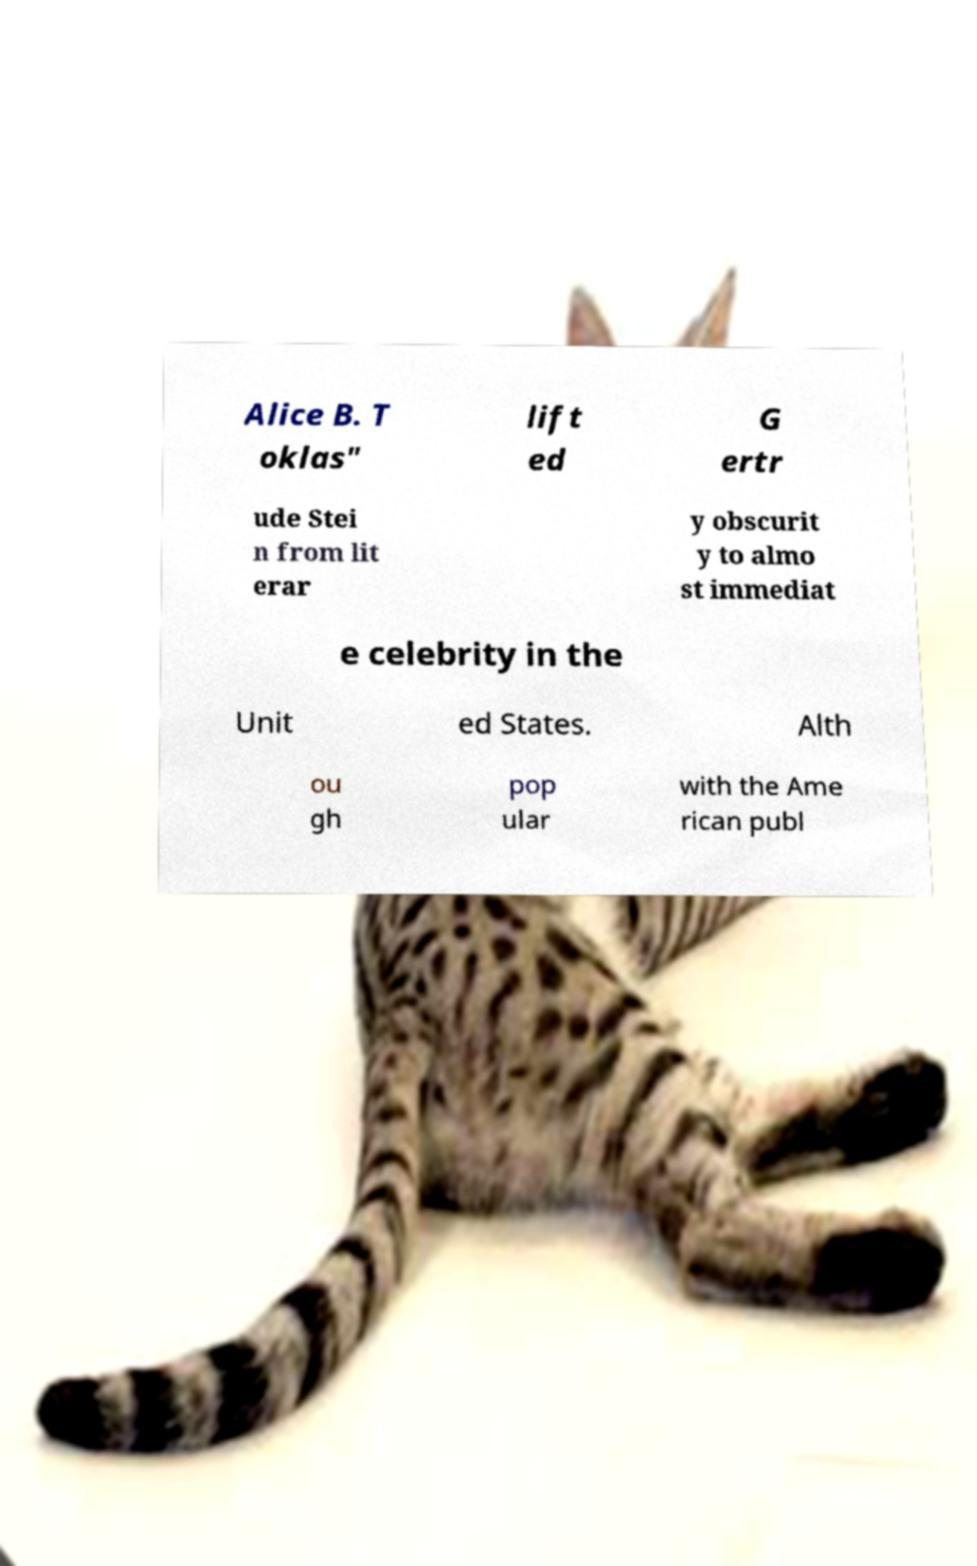Could you assist in decoding the text presented in this image and type it out clearly? Alice B. T oklas" lift ed G ertr ude Stei n from lit erar y obscurit y to almo st immediat e celebrity in the Unit ed States. Alth ou gh pop ular with the Ame rican publ 